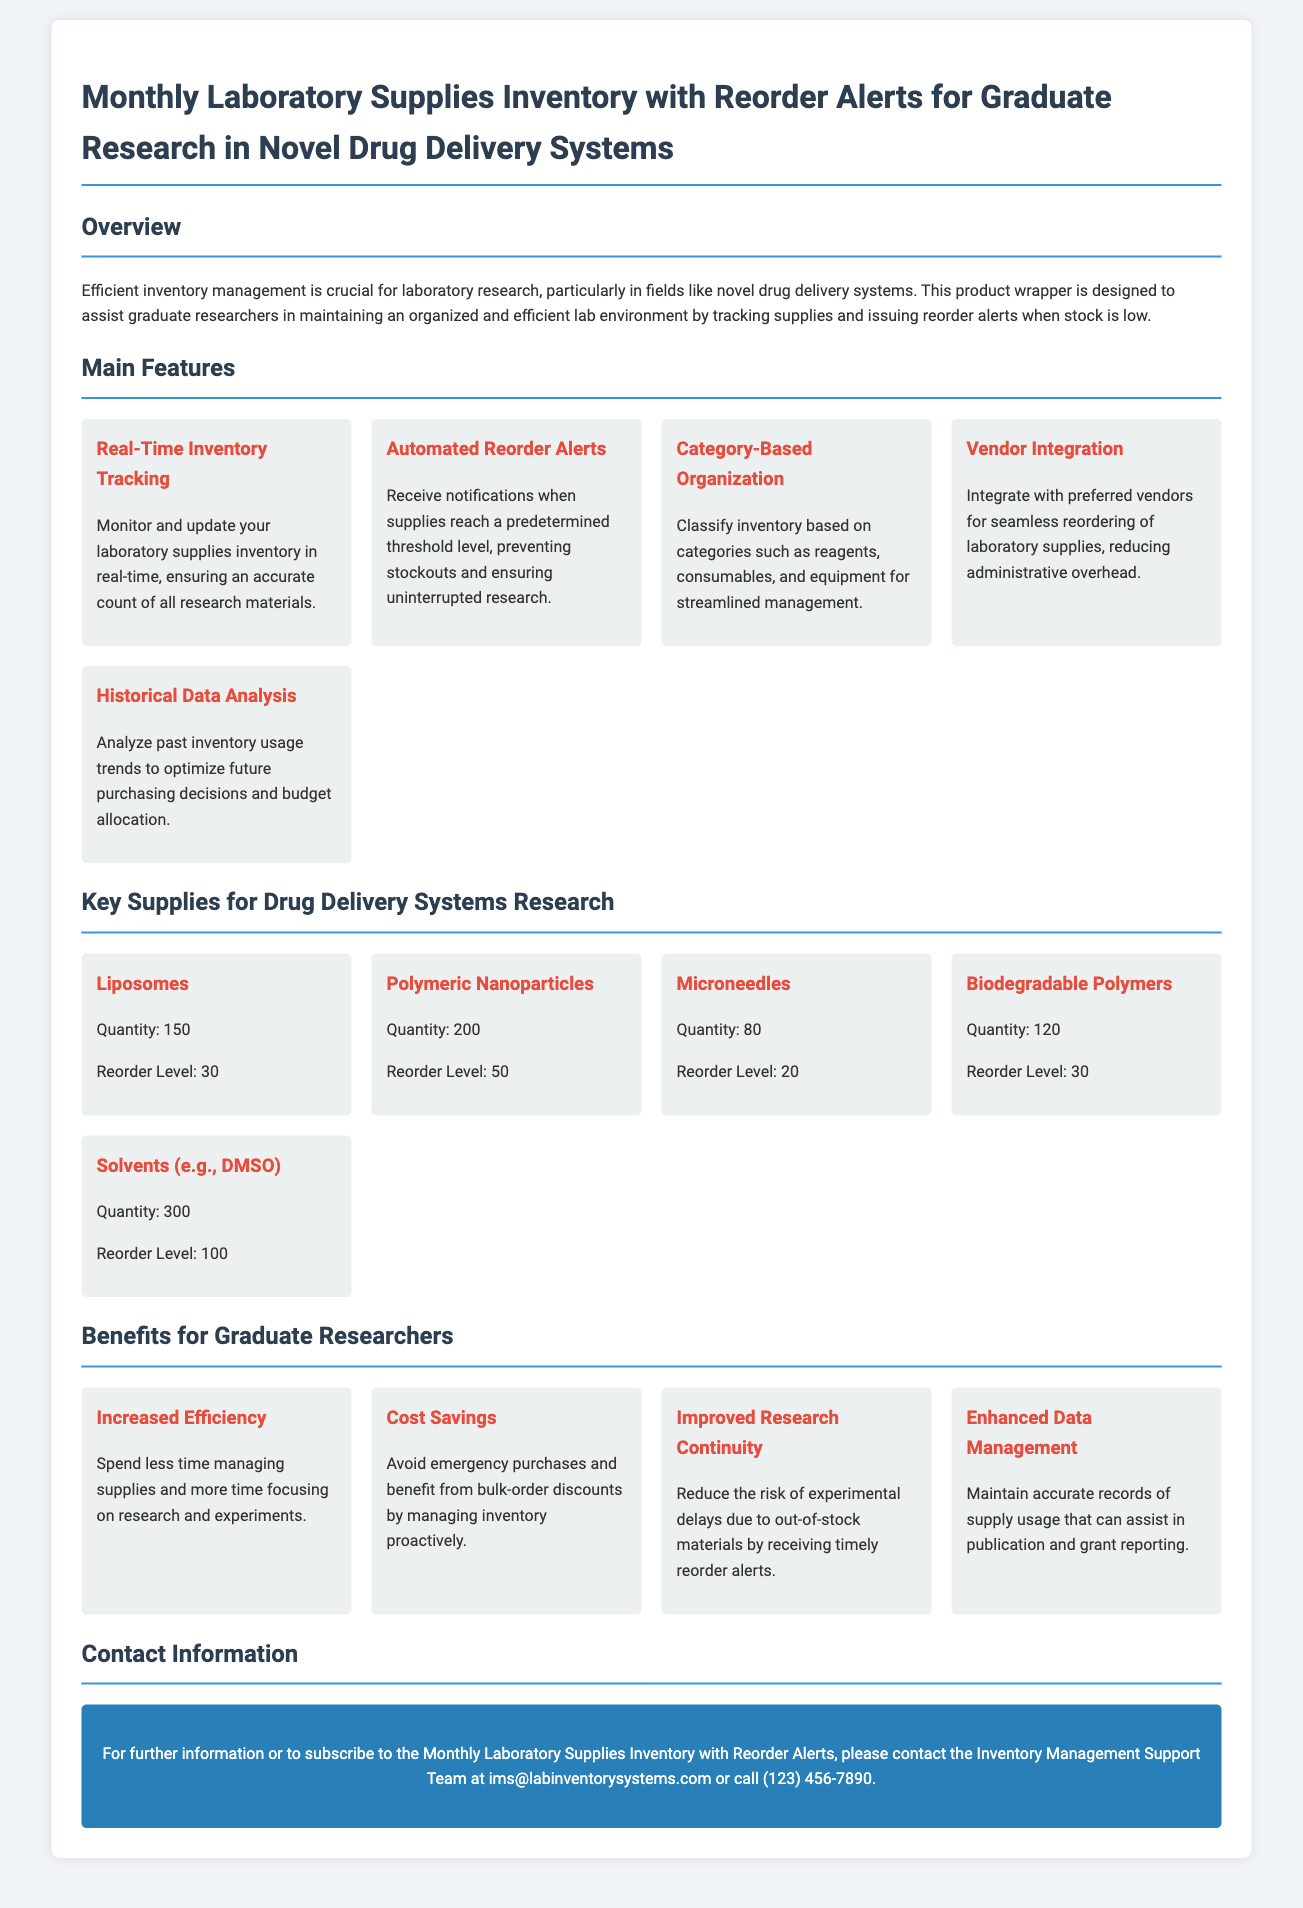What is the title of the document? The document's title is stated at the top and provides a summary of its content.
Answer: Monthly Laboratory Supplies Inventory with Reorder Alerts for Graduate Research in Novel Drug Delivery Systems How many key supplies are listed for drug delivery systems research? The section titled "Key Supplies for Drug Delivery Systems Research" includes a list of supplies.
Answer: 5 What is the reorder level for Liposomes? The reorder level is explicitly mentioned in the supply details for Liposomes.
Answer: 30 Which feature helps in preventing stockouts? The document describes features that assist in inventory management, particularly focused on supplies reaching low levels.
Answer: Automated Reorder Alerts What is the quantity of Polymeric Nanoparticles available? The quantity of each supply is provided in the supply grid for quick reference.
Answer: 200 How does the system benefit graduate researchers in terms of efficiency? The benefits section highlights how the system improves various aspects of research, including time management.
Answer: Increased Efficiency What type of integration does the inventory system offer? The document mentions a feature related to managing relationships with suppliers.
Answer: Vendor Integration What is the contact email for the support team? The contact section provides a way to reach for further inquiries, including an email address.
Answer: ims@labinventorysystems.com 